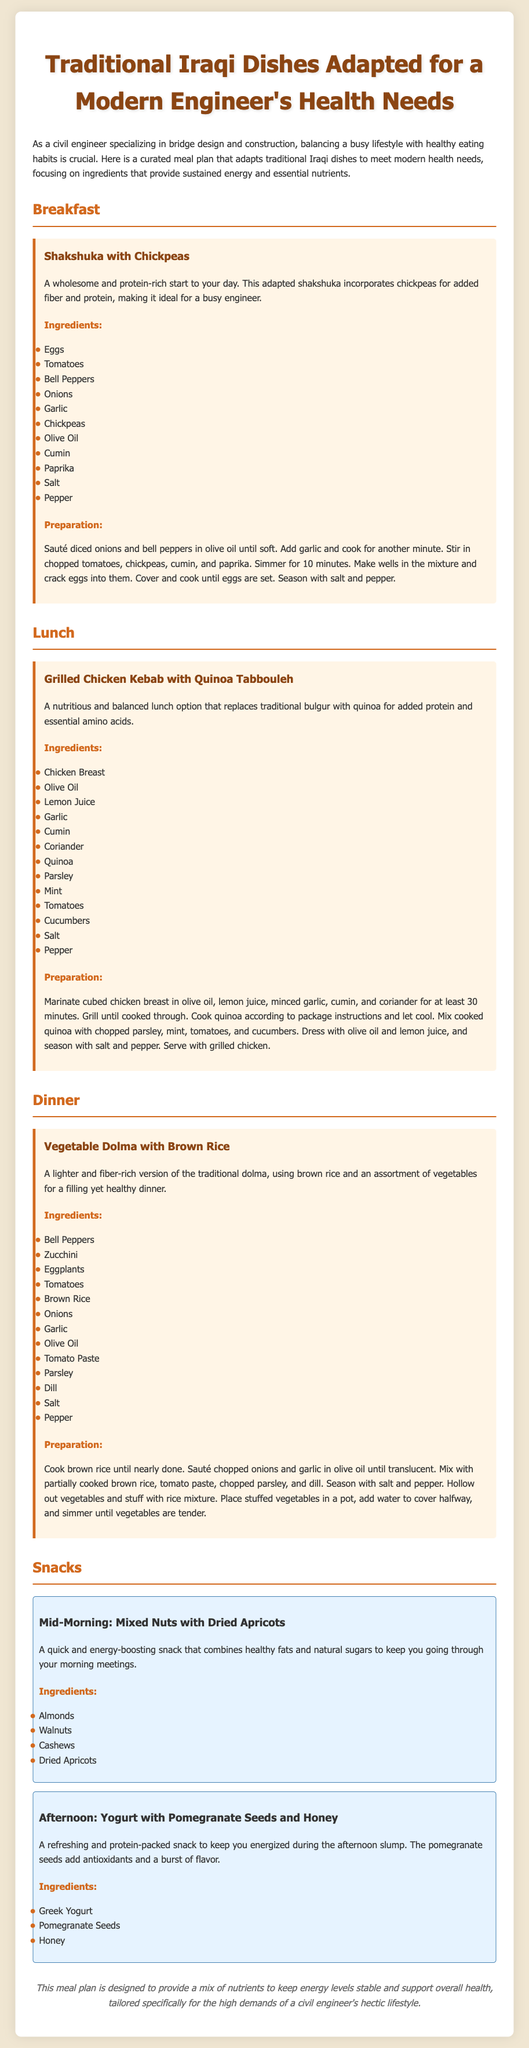What is the title of the meal plan? The title of the meal plan is the heading at the top of the document, indicating its focus on traditional dishes for modern health needs.
Answer: Traditional Iraqi Dishes Adapted for a Modern Engineer's Health Needs What is a key ingredient in Shakshuka with Chickpeas? Shakshuka with Chickpeas includes various ingredients; one key ingredient is a staple component that adds protein and flavor.
Answer: Eggs What type of rice is used in the Vegetable Dolma recipe? The document specifies the type of rice used in the Vegetable Dolma, which is considered healthier than the traditional option.
Answer: Brown Rice How long should the chicken be marinated for the Grilled Chicken Kebab? This question refers to the marination time mentioned in the preparation steps for the Grilled Chicken Kebab.
Answer: 30 minutes What snack combines Greek yogurt and pomegranate seeds? This refers to the afternoon snack section in the meal plan, which lists the ingredients together.
Answer: Yogurt with Pomegranate Seeds and Honey Which vegetable is not included in the Vegetable Dolma recipe? This question involves identifying a vegetable that was deliberately excluded from the recipe list provided in the document.
Answer: N/A (there's no mention of exclusion, just different vegetables included) What breakfast dish is mentioned in the meal plan? The breakfast section features a specific dish that highlights a traditional recipe adapted for health needs.
Answer: Shakshuka with Chickpeas What main protein source is used in the lunch option? This question focuses on the primary protein source in the lunch meal mentioned in the document.
Answer: Chicken Breast 